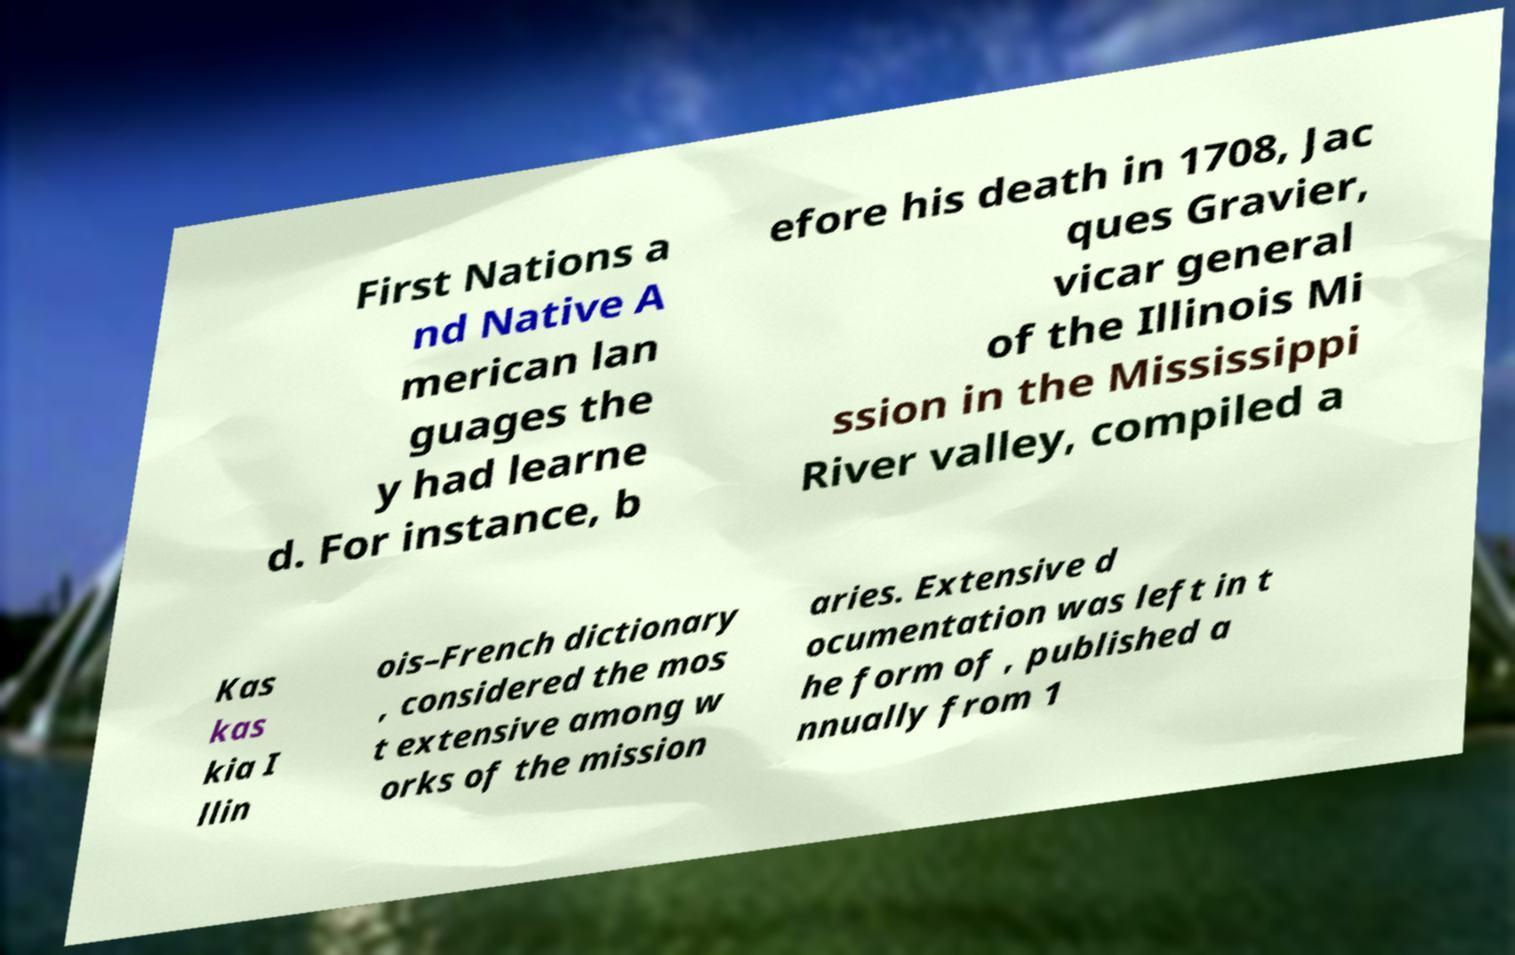Could you extract and type out the text from this image? First Nations a nd Native A merican lan guages the y had learne d. For instance, b efore his death in 1708, Jac ques Gravier, vicar general of the Illinois Mi ssion in the Mississippi River valley, compiled a Kas kas kia I llin ois–French dictionary , considered the mos t extensive among w orks of the mission aries. Extensive d ocumentation was left in t he form of , published a nnually from 1 